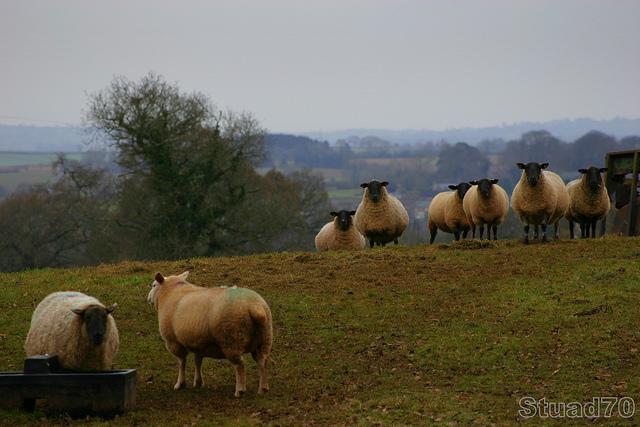How many sheep are there?
Keep it brief. 8. What type of animals are shown?
Short answer required. Sheep. How many sheep are looking towards the camera?
Be succinct. 7. Are there a lot of babies?
Keep it brief. No. Why is there green on this animal?
Be succinct. No. What number is shown?
Quick response, please. 70. Is this copyrighted?
Short answer required. Yes. 